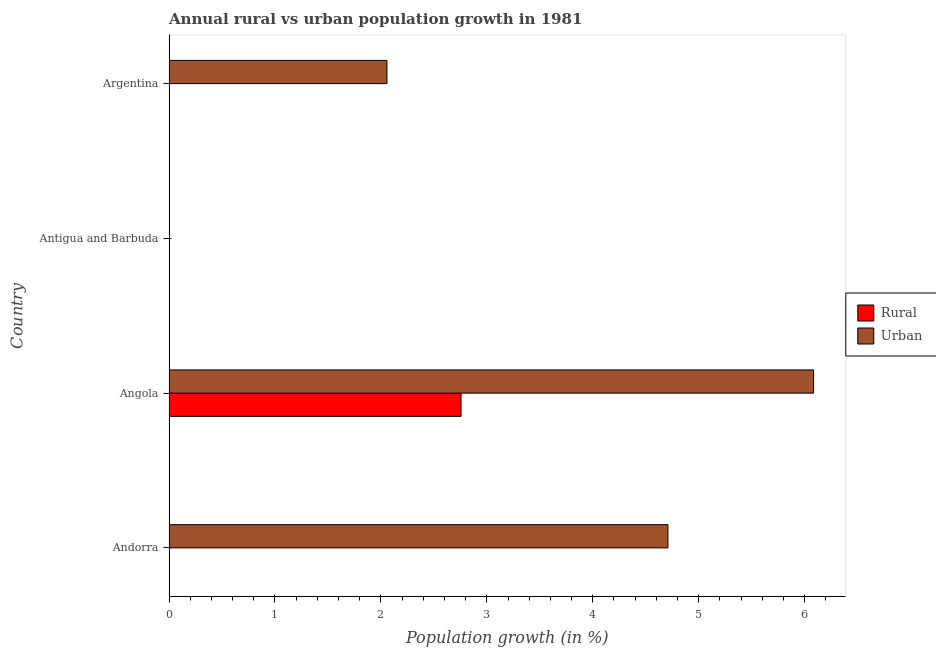How many different coloured bars are there?
Keep it short and to the point. 2. How many bars are there on the 2nd tick from the top?
Provide a short and direct response. 0. How many bars are there on the 4th tick from the bottom?
Your answer should be compact. 1. In how many cases, is the number of bars for a given country not equal to the number of legend labels?
Offer a terse response. 3. Across all countries, what is the maximum rural population growth?
Give a very brief answer. 2.76. In which country was the urban population growth maximum?
Keep it short and to the point. Angola. What is the total urban population growth in the graph?
Keep it short and to the point. 12.85. What is the difference between the rural population growth in Andorra and the urban population growth in Antigua and Barbuda?
Your answer should be very brief. 0. What is the average rural population growth per country?
Ensure brevity in your answer.  0.69. What is the difference between the rural population growth and urban population growth in Angola?
Keep it short and to the point. -3.33. In how many countries, is the urban population growth greater than 0.4 %?
Offer a terse response. 3. What is the ratio of the urban population growth in Andorra to that in Angola?
Your response must be concise. 0.77. What is the difference between the highest and the second highest urban population growth?
Offer a very short reply. 1.38. What is the difference between the highest and the lowest urban population growth?
Keep it short and to the point. 6.08. How many bars are there?
Your response must be concise. 4. Are all the bars in the graph horizontal?
Provide a succinct answer. Yes. How many countries are there in the graph?
Provide a short and direct response. 4. What is the difference between two consecutive major ticks on the X-axis?
Keep it short and to the point. 1. Are the values on the major ticks of X-axis written in scientific E-notation?
Provide a succinct answer. No. Does the graph contain any zero values?
Your answer should be very brief. Yes. Does the graph contain grids?
Keep it short and to the point. No. How many legend labels are there?
Offer a very short reply. 2. How are the legend labels stacked?
Your answer should be very brief. Vertical. What is the title of the graph?
Provide a succinct answer. Annual rural vs urban population growth in 1981. Does "Quality of trade" appear as one of the legend labels in the graph?
Your answer should be compact. No. What is the label or title of the X-axis?
Make the answer very short. Population growth (in %). What is the label or title of the Y-axis?
Give a very brief answer. Country. What is the Population growth (in %) in Urban  in Andorra?
Offer a terse response. 4.71. What is the Population growth (in %) in Rural in Angola?
Make the answer very short. 2.76. What is the Population growth (in %) in Urban  in Angola?
Keep it short and to the point. 6.08. What is the Population growth (in %) in Rural in Argentina?
Offer a terse response. 0. What is the Population growth (in %) of Urban  in Argentina?
Provide a short and direct response. 2.06. Across all countries, what is the maximum Population growth (in %) in Rural?
Your response must be concise. 2.76. Across all countries, what is the maximum Population growth (in %) in Urban ?
Offer a very short reply. 6.08. What is the total Population growth (in %) of Rural in the graph?
Give a very brief answer. 2.76. What is the total Population growth (in %) of Urban  in the graph?
Offer a terse response. 12.85. What is the difference between the Population growth (in %) of Urban  in Andorra and that in Angola?
Make the answer very short. -1.37. What is the difference between the Population growth (in %) of Urban  in Andorra and that in Argentina?
Provide a succinct answer. 2.65. What is the difference between the Population growth (in %) in Urban  in Angola and that in Argentina?
Ensure brevity in your answer.  4.03. What is the difference between the Population growth (in %) in Rural in Angola and the Population growth (in %) in Urban  in Argentina?
Provide a succinct answer. 0.7. What is the average Population growth (in %) of Rural per country?
Make the answer very short. 0.69. What is the average Population growth (in %) in Urban  per country?
Give a very brief answer. 3.21. What is the difference between the Population growth (in %) in Rural and Population growth (in %) in Urban  in Angola?
Your answer should be very brief. -3.33. What is the ratio of the Population growth (in %) in Urban  in Andorra to that in Angola?
Offer a very short reply. 0.77. What is the ratio of the Population growth (in %) in Urban  in Andorra to that in Argentina?
Offer a very short reply. 2.29. What is the ratio of the Population growth (in %) in Urban  in Angola to that in Argentina?
Provide a short and direct response. 2.96. What is the difference between the highest and the second highest Population growth (in %) of Urban ?
Provide a short and direct response. 1.37. What is the difference between the highest and the lowest Population growth (in %) in Rural?
Provide a succinct answer. 2.76. What is the difference between the highest and the lowest Population growth (in %) in Urban ?
Ensure brevity in your answer.  6.08. 